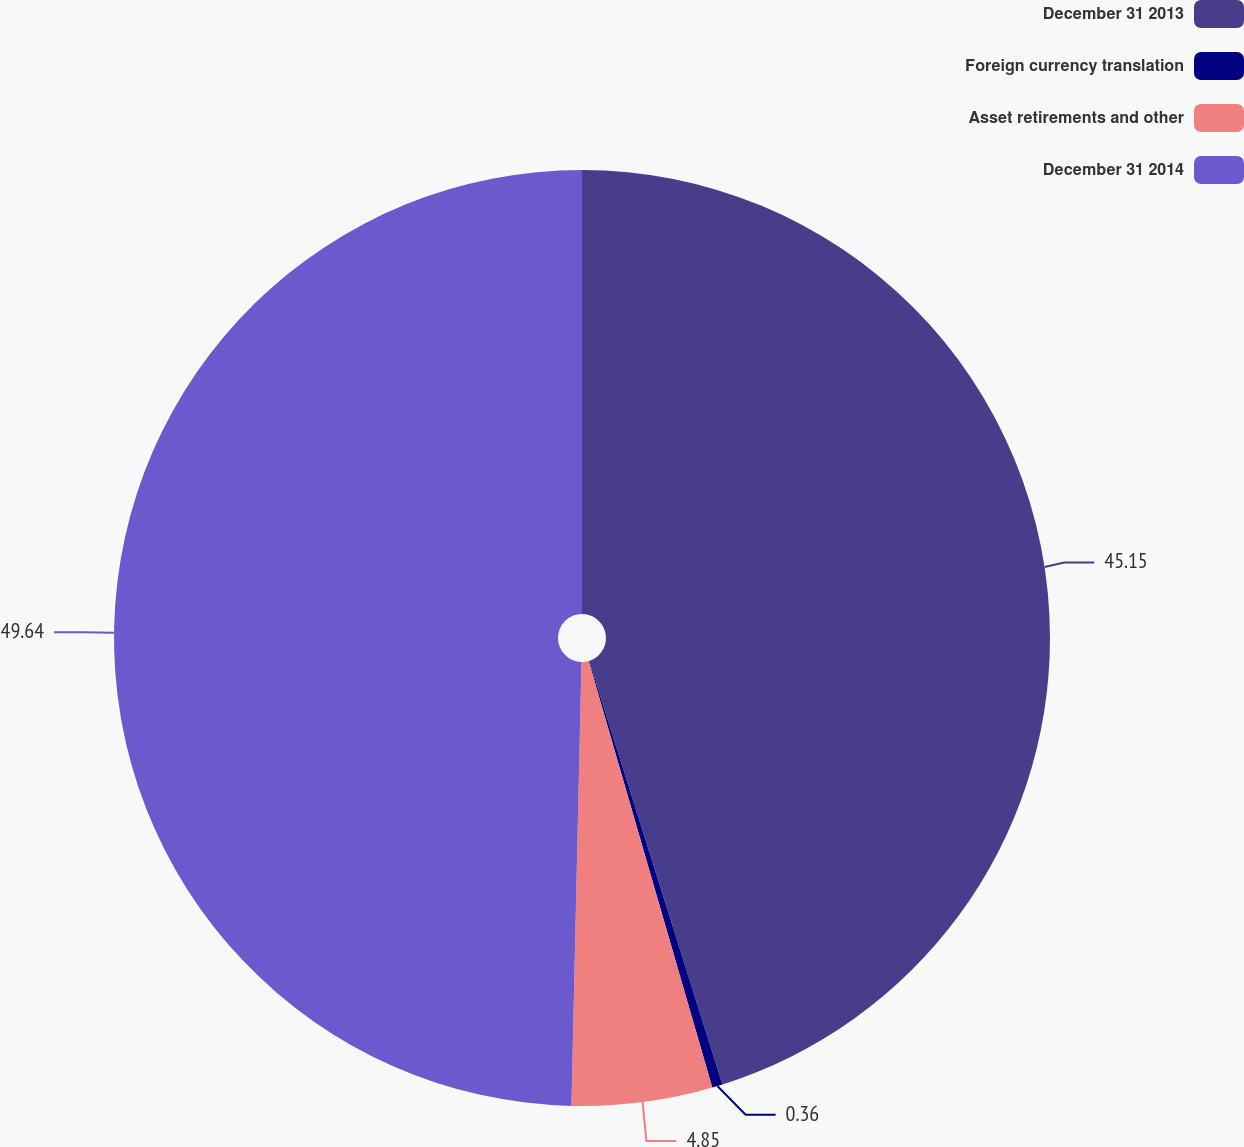Convert chart. <chart><loc_0><loc_0><loc_500><loc_500><pie_chart><fcel>December 31 2013<fcel>Foreign currency translation<fcel>Asset retirements and other<fcel>December 31 2014<nl><fcel>45.15%<fcel>0.36%<fcel>4.85%<fcel>49.64%<nl></chart> 